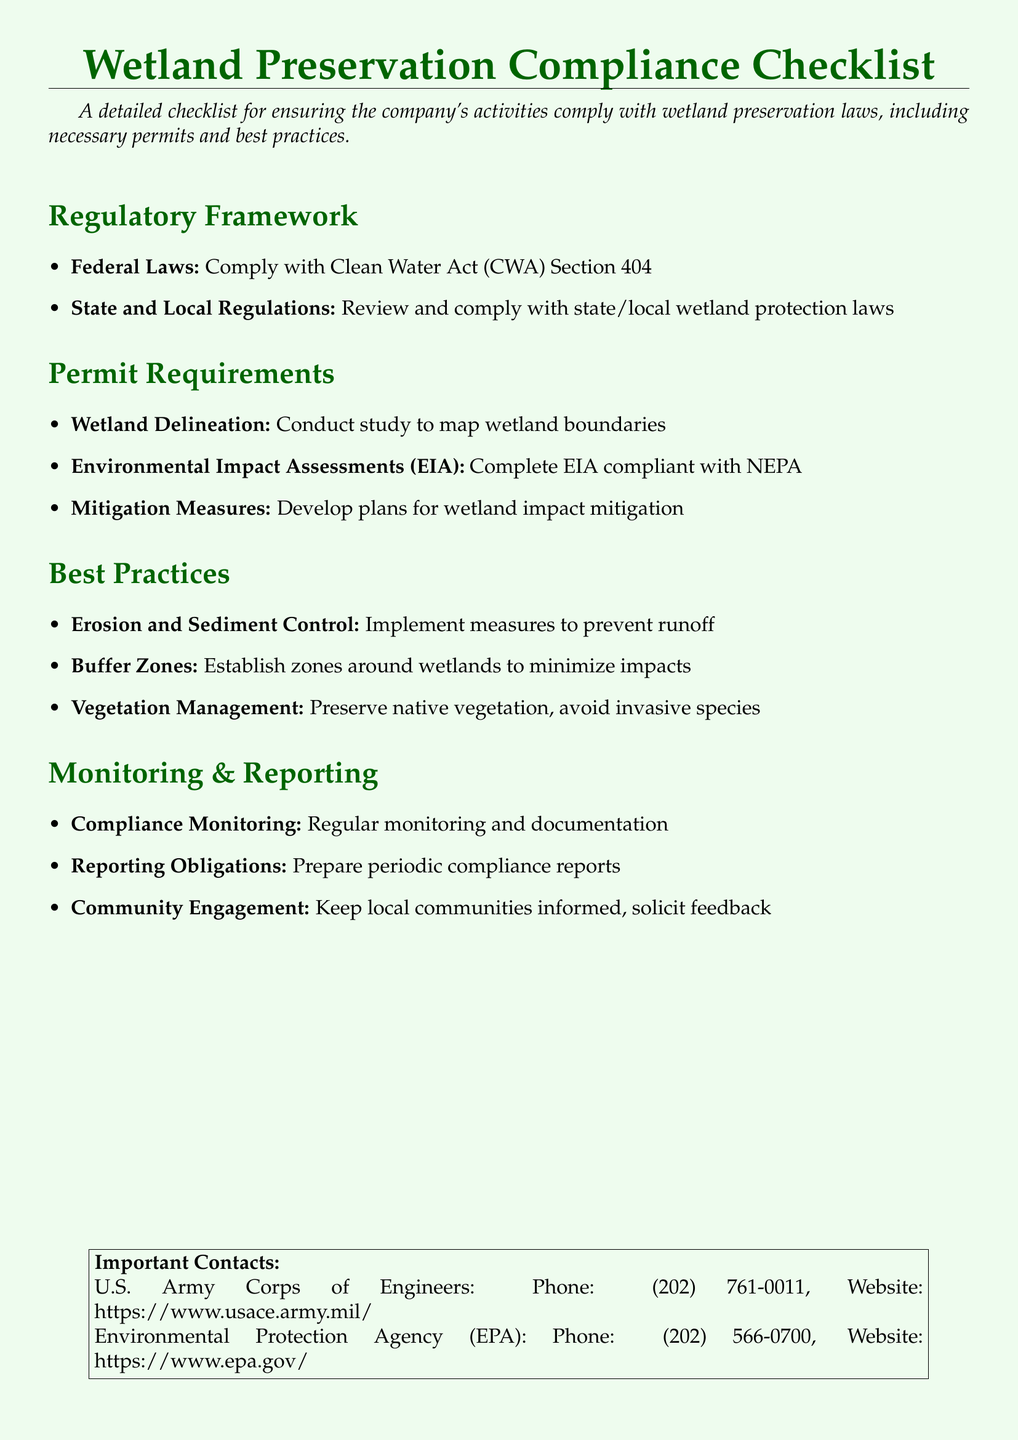What are the federal laws referenced? The federal laws referenced include those that require compliance with the Clean Water Act (CWA) Section 404.
Answer: Clean Water Act (CWA) Section 404 What must be conducted to map wetland boundaries? A study must be conducted specifically for mapping wetland boundaries, referred to as wetland delineation.
Answer: Wetland Delineation What does EIA stand for? EIA stands for Environmental Impact Assessments, which must comply with NEPA.
Answer: Environmental Impact Assessments What type of control measures are suggested? Erosion and sediment control measures are suggested to prevent runoff.
Answer: Erosion and Sediment Control What is the frequency of compliance monitoring? The document implies that compliance monitoring should be regular, but does not specify a frequency.
Answer: Regular What must be developed for wetland impact? Plans must be developed for wetland impact mitigation as part of the compliance process.
Answer: Mitigation Measures Which document requires the EIA to comply? The EIA is required to be compliant with the National Environmental Policy Act (NEPA).
Answer: NEPA Who should be kept informed according to the checklist? Local communities should be kept informed and their feedback solicited as part of the monitoring and reporting process.
Answer: Local communities 